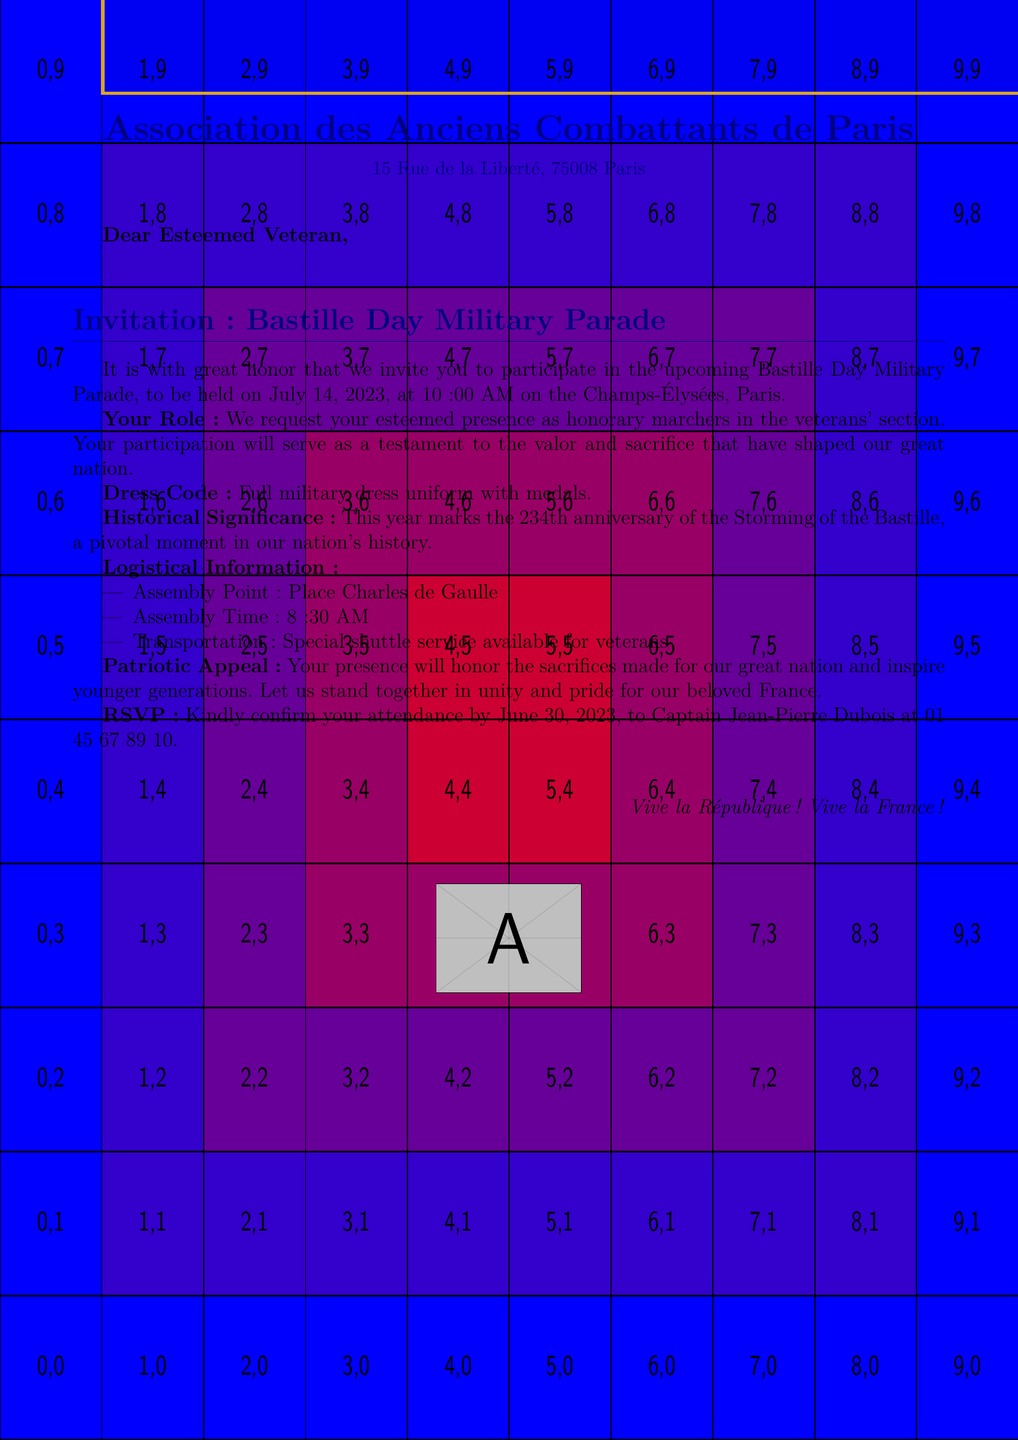What is the date of the parade? The date of the parade is mentioned in the event details section of the document.
Answer: July 14, 2023 Who should be contacted to RSVP? The contact information for RSVP is provided in the RSVP section of the document.
Answer: Captain Jean-Pierre Dubois What is the dress code for the event? The dress code is specified in the participation request section.
Answer: Full military dress uniform with medals What is the assembly time for participants? The assembly time is listed under the logistical information section of the document.
Answer: 8:30 AM Why is the event significant this year? The historical significance is provided in the document, explaining the reason for the anniversary.
Answer: 234th anniversary of the Storming of the Bastille What role are veterans asked to take during the parade? The specific role for veterans is mentioned in the participation request part of the document.
Answer: Honorary marchers in the veterans' section When is the RSVP deadline? The deadline to confirm attendance is included in the RSVP section of the document.
Answer: June 30, 2023 